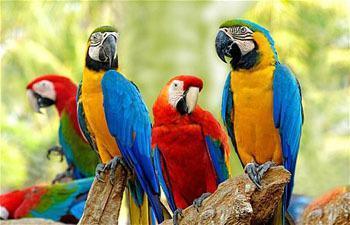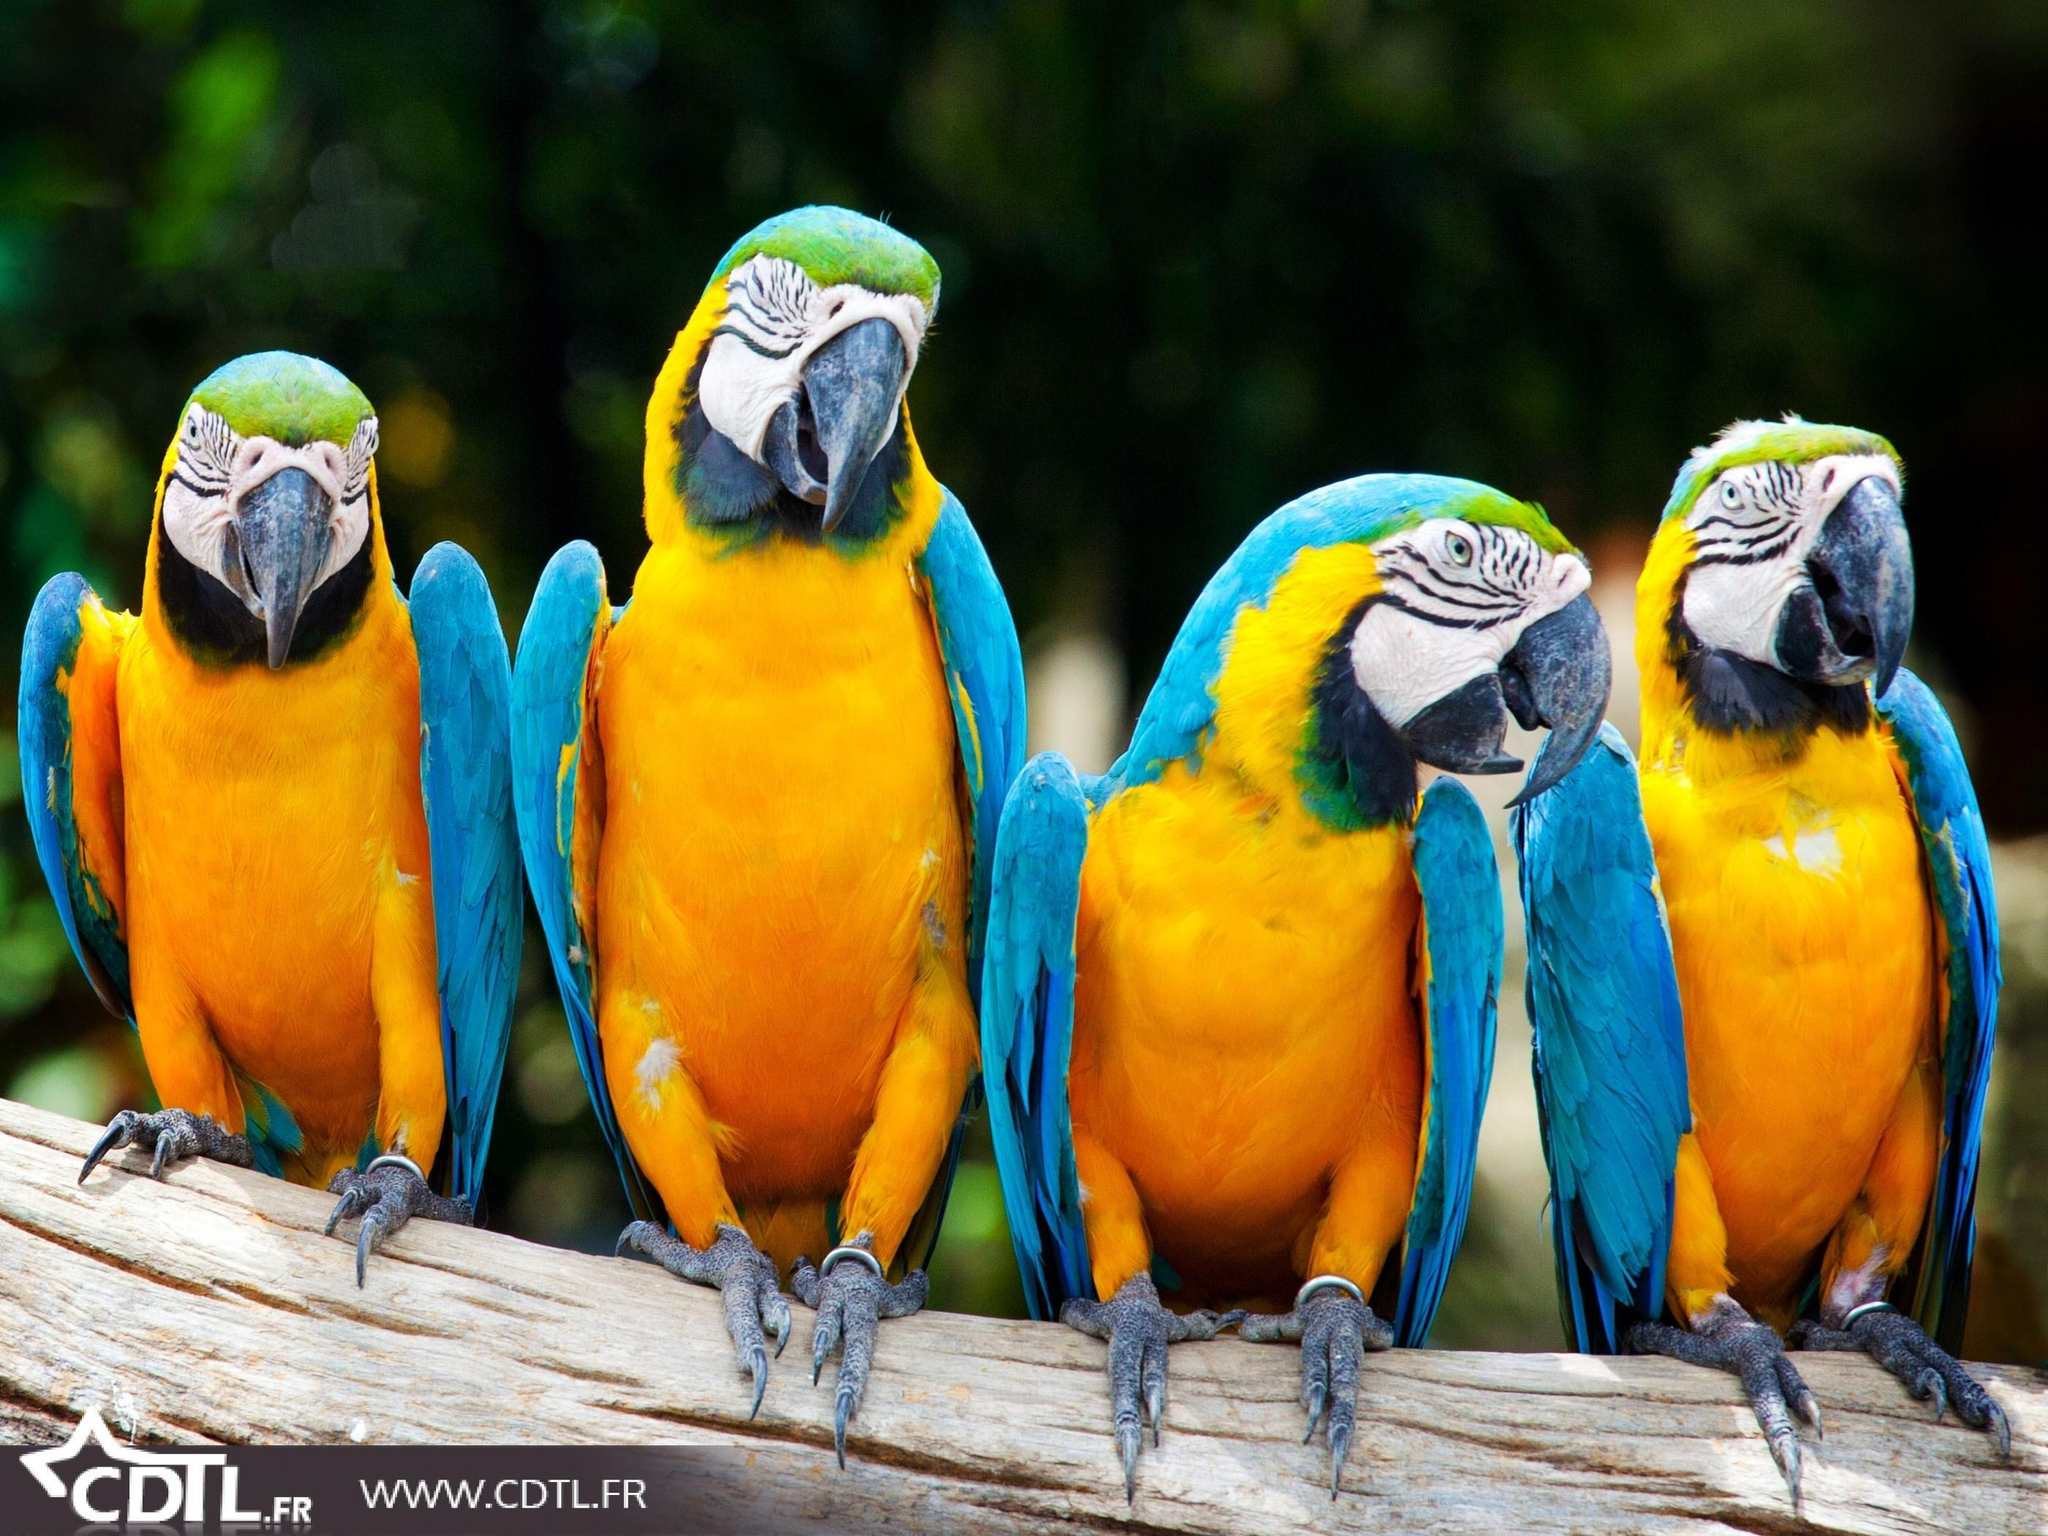The first image is the image on the left, the second image is the image on the right. For the images displayed, is the sentence "There are at least four birds in the image on the right." factually correct? Answer yes or no. Yes. 